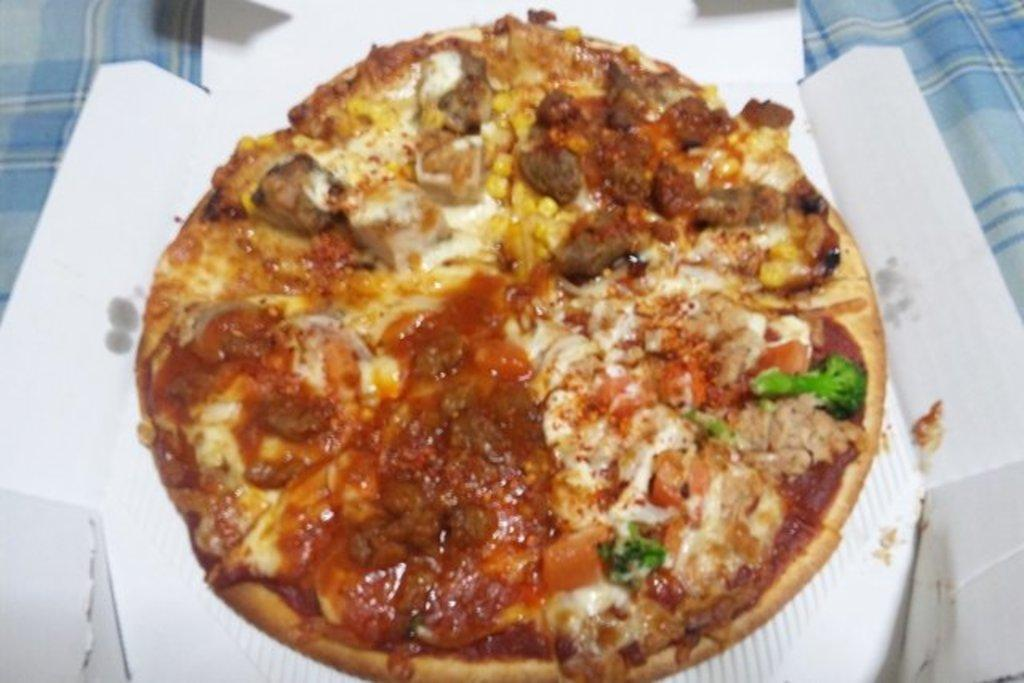What type of food is visible in the image? There is a pizza in the image. Where is the pizza placed? The pizza is on a white box. What colors are present in the cloth at the bottom of the image? The cloth at the bottom of the image is sky blue and white. How much profit did the pizza make during the vacation in the snow? There is no information about profit, vacation, or snow in the image, as it only features a pizza on a white box and a sky blue and white cloth at the bottom. 